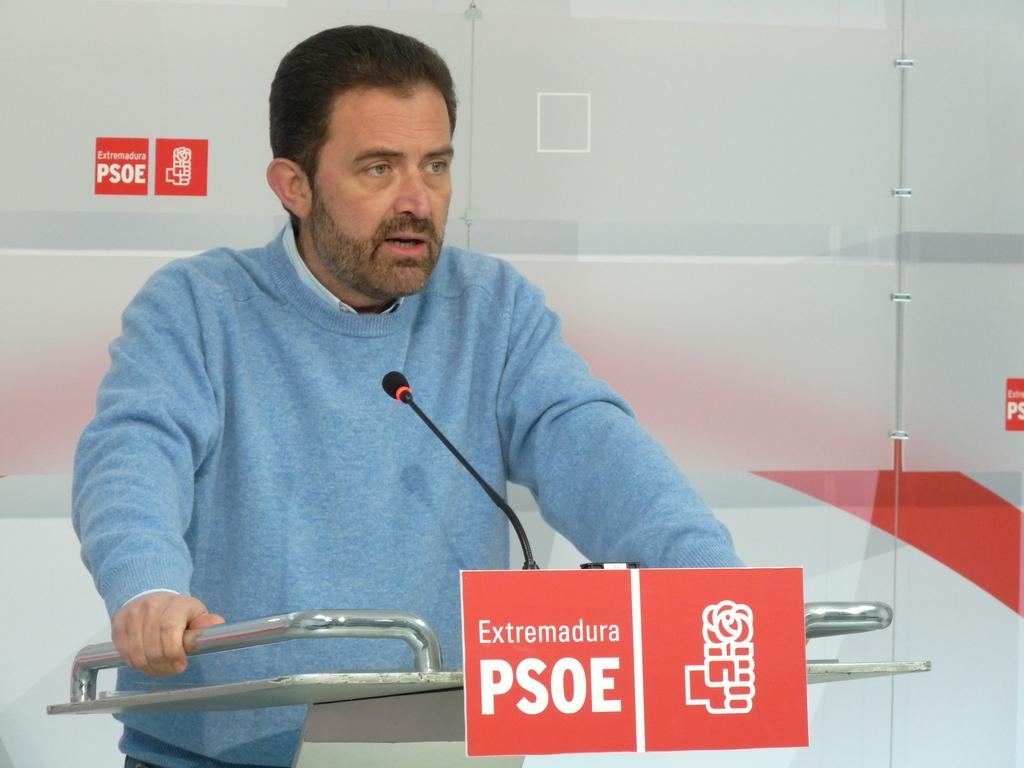Who is the main subject in the image? There is a man in the center of the image. What is the man wearing? The man is wearing a blue sweater. What is the man doing in the image? The man is standing behind a podium. What object is the man using to amplify his voice? There is a microphone in the image. What type of objects can be seen in the background of the image? There are metal rods in the image. What can be read on the posters in the image? There is text on posters in the image. What type of thrill can be seen in the man's eyes in the image? There is no indication of the man's emotions or expressions in the image, so it cannot be determined if there is any thrill in his eyes. 